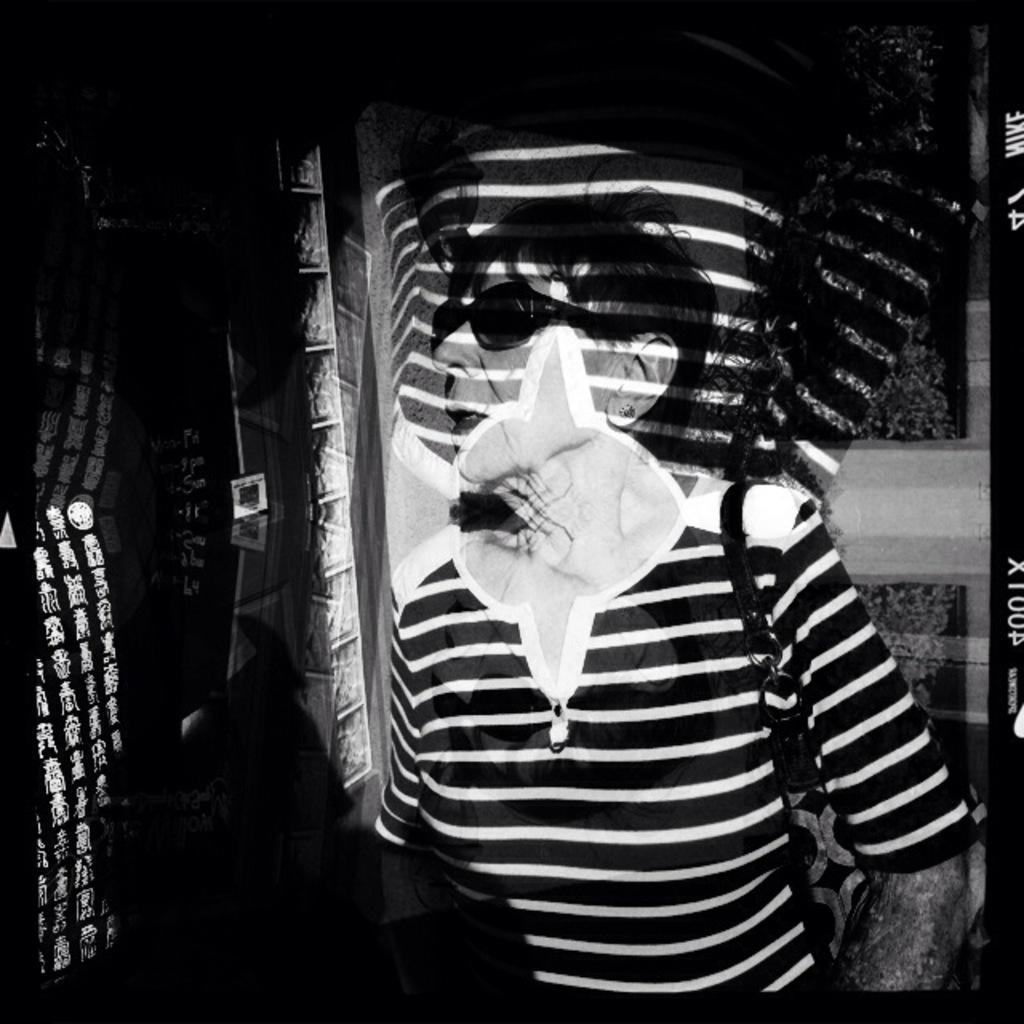Can you describe this image briefly? This is a black and white image, in this image there is a woman. 